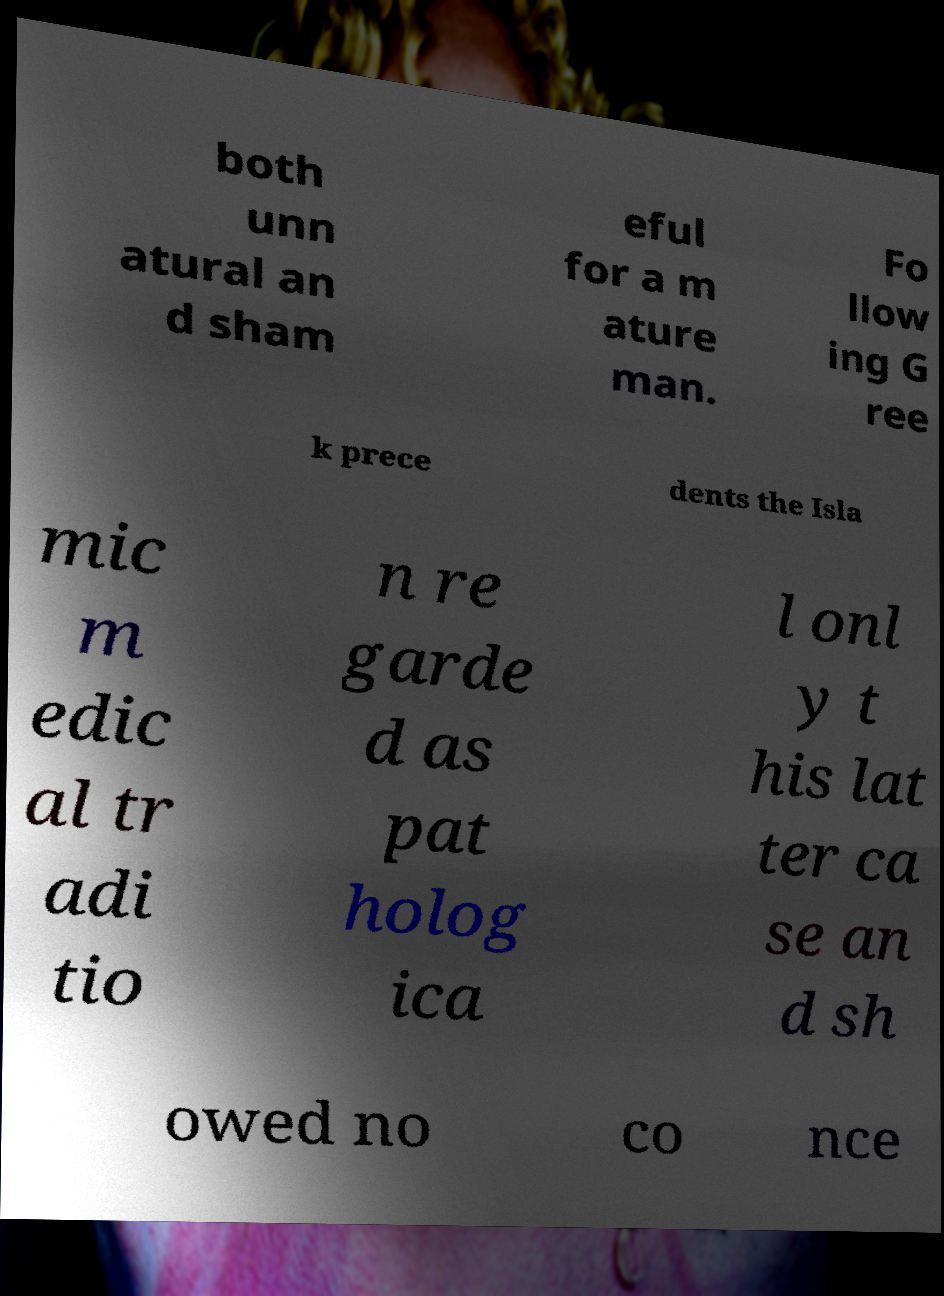Could you extract and type out the text from this image? both unn atural an d sham eful for a m ature man. Fo llow ing G ree k prece dents the Isla mic m edic al tr adi tio n re garde d as pat holog ica l onl y t his lat ter ca se an d sh owed no co nce 